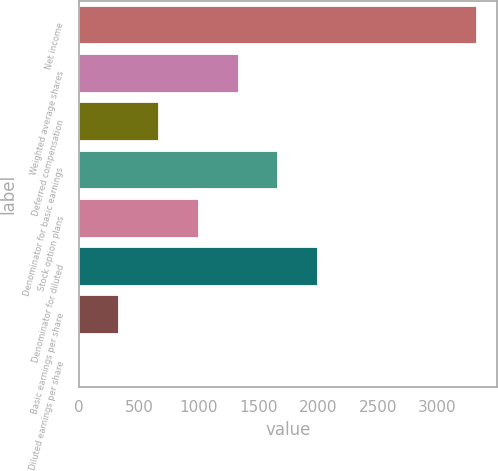Convert chart. <chart><loc_0><loc_0><loc_500><loc_500><bar_chart><fcel>Net income<fcel>Weighted average shares<fcel>Deferred compensation<fcel>Denominator for basic earnings<fcel>Stock option plans<fcel>Denominator for diluted<fcel>Basic earnings per share<fcel>Diluted earnings per share<nl><fcel>3333<fcel>1334.97<fcel>668.95<fcel>1667.98<fcel>1001.96<fcel>2000.99<fcel>335.94<fcel>2.93<nl></chart> 